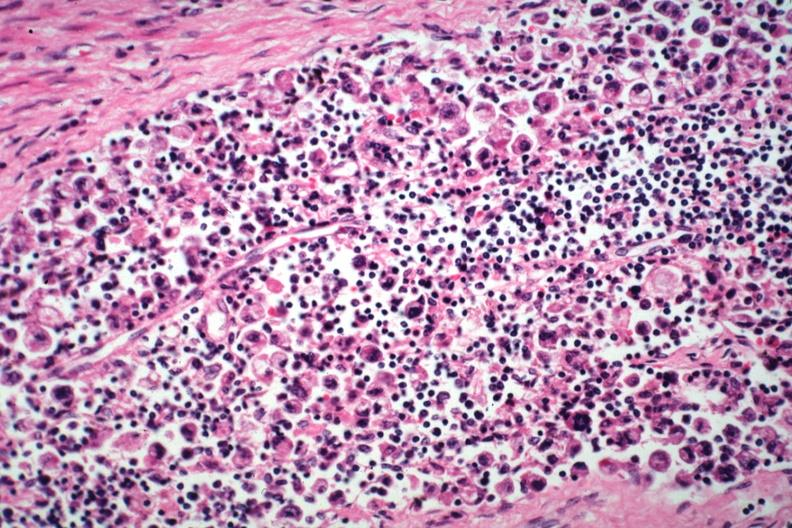what is incidental finding died?
Answer the question using a single word or phrase. With promyelocytic leukemia stomach lesion # 